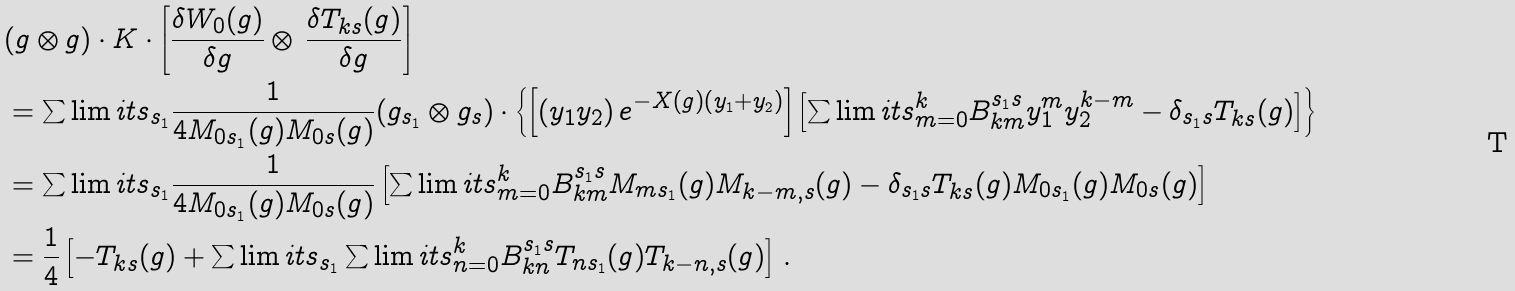Convert formula to latex. <formula><loc_0><loc_0><loc_500><loc_500>& ( g \otimes g ) \cdot K \cdot \left [ \frac { \delta W _ { 0 } ( g ) } { \delta g } \otimes \, \frac { \delta T _ { k s } ( g ) } { \delta g } \right ] \\ & = \sum \lim i t s _ { s _ { 1 } } \frac { 1 } { 4 M _ { 0 s _ { 1 } } ( g ) M _ { 0 s } ( g ) } ( g _ { s _ { 1 } } \otimes g _ { s } ) \cdot \left \{ \left [ \left ( y _ { 1 } y _ { 2 } \right ) e ^ { - X ( g ) \left ( y _ { 1 } + y _ { 2 } \right ) } \right ] \left [ \sum \lim i t s _ { m = 0 } ^ { k } B _ { k m } ^ { s _ { 1 } s } y _ { 1 } ^ { m } y _ { 2 } ^ { k - m } - \delta _ { s _ { 1 } s } T _ { k s } ( g ) \right ] \right \} \\ & = \sum \lim i t s _ { s _ { 1 } } \frac { 1 } { 4 M _ { 0 s _ { 1 } } ( g ) M _ { 0 s } ( g ) } \left [ \sum \lim i t s _ { m = 0 } ^ { k } B _ { k m } ^ { s _ { 1 } s } M _ { m s _ { 1 } } ( g ) M _ { k - m , s } ( g ) - \delta _ { s _ { 1 } s } T _ { k s } ( g ) M _ { 0 s _ { 1 } } ( g ) M _ { 0 s } ( g ) \right ] \\ & = \frac { 1 } { 4 } \left [ - T _ { k s } ( g ) + \sum \lim i t s _ { s _ { 1 } } \sum \lim i t s _ { n = 0 } ^ { k } B _ { k n } ^ { s _ { 1 } s } T _ { n s _ { 1 } } ( g ) T _ { k - n , s } ( g ) \right ] \, .</formula> 